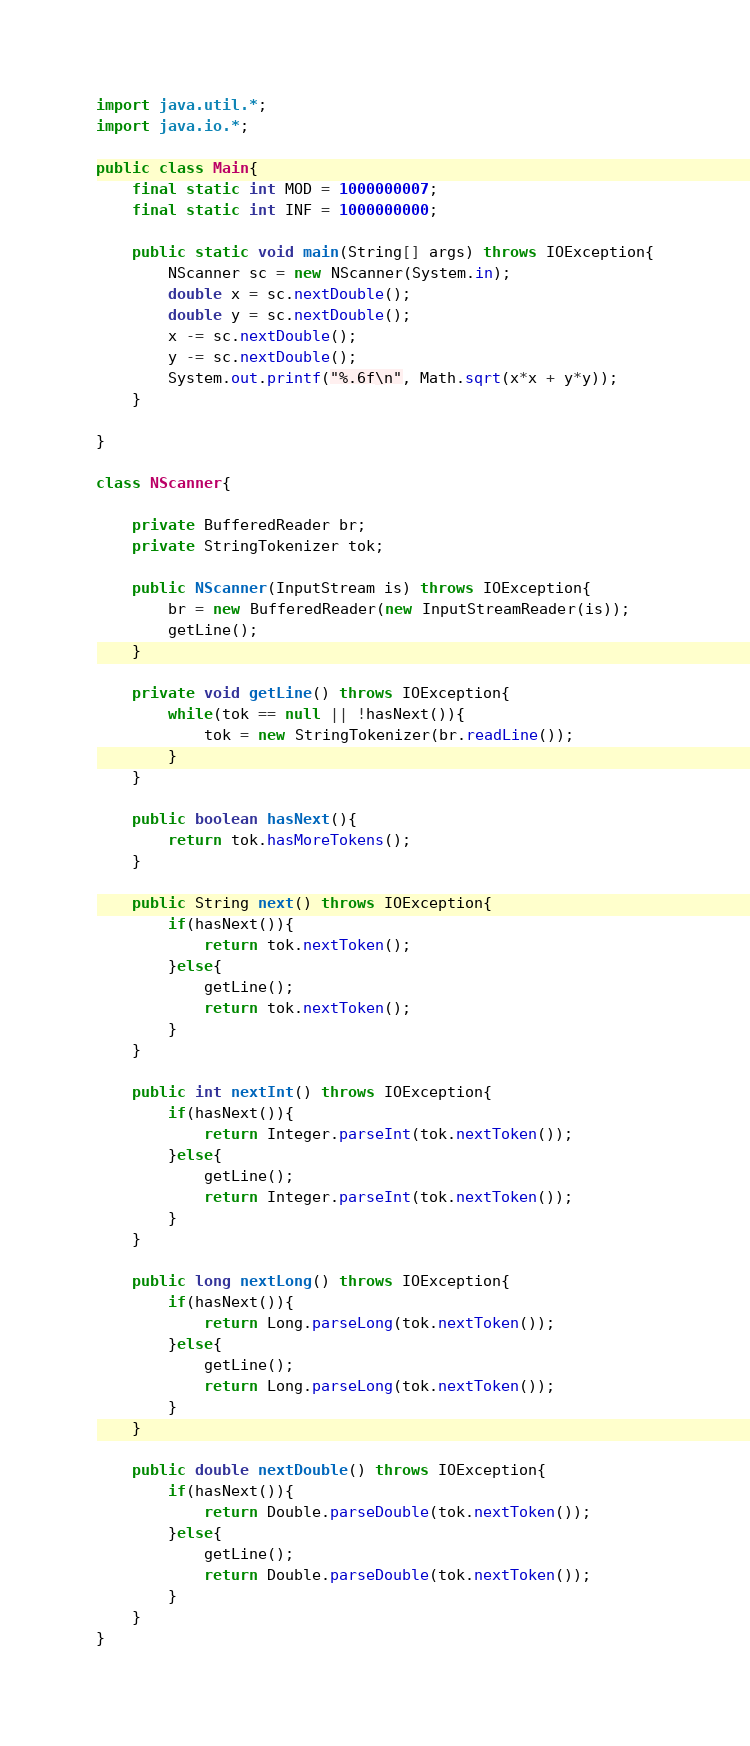Convert code to text. <code><loc_0><loc_0><loc_500><loc_500><_Java_>import java.util.*;
import java.io.*;

public class Main{
	final static int MOD = 1000000007;
	final static int INF = 1000000000;

	public static void main(String[] args) throws IOException{
		NScanner sc = new NScanner(System.in);
		double x = sc.nextDouble();
		double y = sc.nextDouble();
		x -= sc.nextDouble();
		y -= sc.nextDouble();
		System.out.printf("%.6f\n", Math.sqrt(x*x + y*y));
	}

}

class NScanner{

	private BufferedReader br;
	private StringTokenizer tok;

	public NScanner(InputStream is) throws IOException{
		br = new BufferedReader(new InputStreamReader(is));
		getLine();
	}

	private void getLine() throws IOException{
		while(tok == null || !hasNext()){
			tok = new StringTokenizer(br.readLine());
		}
	}

	public boolean hasNext(){
		return tok.hasMoreTokens();
	}

	public String next() throws IOException{
		if(hasNext()){
			return tok.nextToken();
		}else{
			getLine();
			return tok.nextToken();
		}
	}

	public int nextInt() throws IOException{
		if(hasNext()){
			return Integer.parseInt(tok.nextToken());
		}else{
			getLine();
			return Integer.parseInt(tok.nextToken());
		}
	}

	public long nextLong() throws IOException{
		if(hasNext()){
			return Long.parseLong(tok.nextToken());
		}else{
			getLine();
			return Long.parseLong(tok.nextToken());
		}
	}

	public double nextDouble() throws IOException{
		if(hasNext()){
			return Double.parseDouble(tok.nextToken());
		}else{
			getLine();
			return Double.parseDouble(tok.nextToken());
		}
	}
}
</code> 